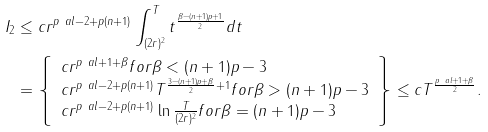Convert formula to latex. <formula><loc_0><loc_0><loc_500><loc_500>I _ { 2 } & \leq c r ^ { p \ a l - 2 + p ( n + 1 ) } \int _ { ( 2 r ) ^ { 2 } } ^ { T } t ^ { \frac { \beta - ( n + 1 ) p + 1 } { 2 } } d t \\ & = \left \{ \begin{array} { l } c r ^ { p \ a l + 1 + \beta } f o r \beta < ( n + 1 ) p - 3 \\ c r ^ { p \ a l - 2 + p ( n + 1 ) } T ^ { \frac { 3 - ( n + 1 ) p + \beta } { 2 } + 1 } f o r \beta > ( n + 1 ) p - 3 \\ c r ^ { p \ a l - 2 + p ( n + 1 ) } \ln \frac { T } { ( 2 r ) ^ { 2 } } f o r \beta = ( n + 1 ) p - 3 \end{array} \right \} \leq c T ^ { \frac { p \ a l + 1 + \beta } { 2 } } .</formula> 